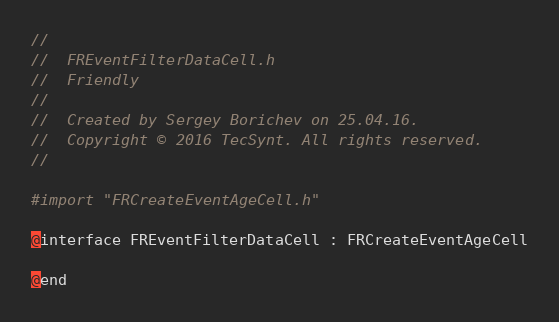Convert code to text. <code><loc_0><loc_0><loc_500><loc_500><_C_>//
//  FREventFilterDataCell.h
//  Friendly
//
//  Created by Sergey Borichev on 25.04.16.
//  Copyright © 2016 TecSynt. All rights reserved.
//

#import "FRCreateEventAgeCell.h"

@interface FREventFilterDataCell : FRCreateEventAgeCell

@end
</code> 